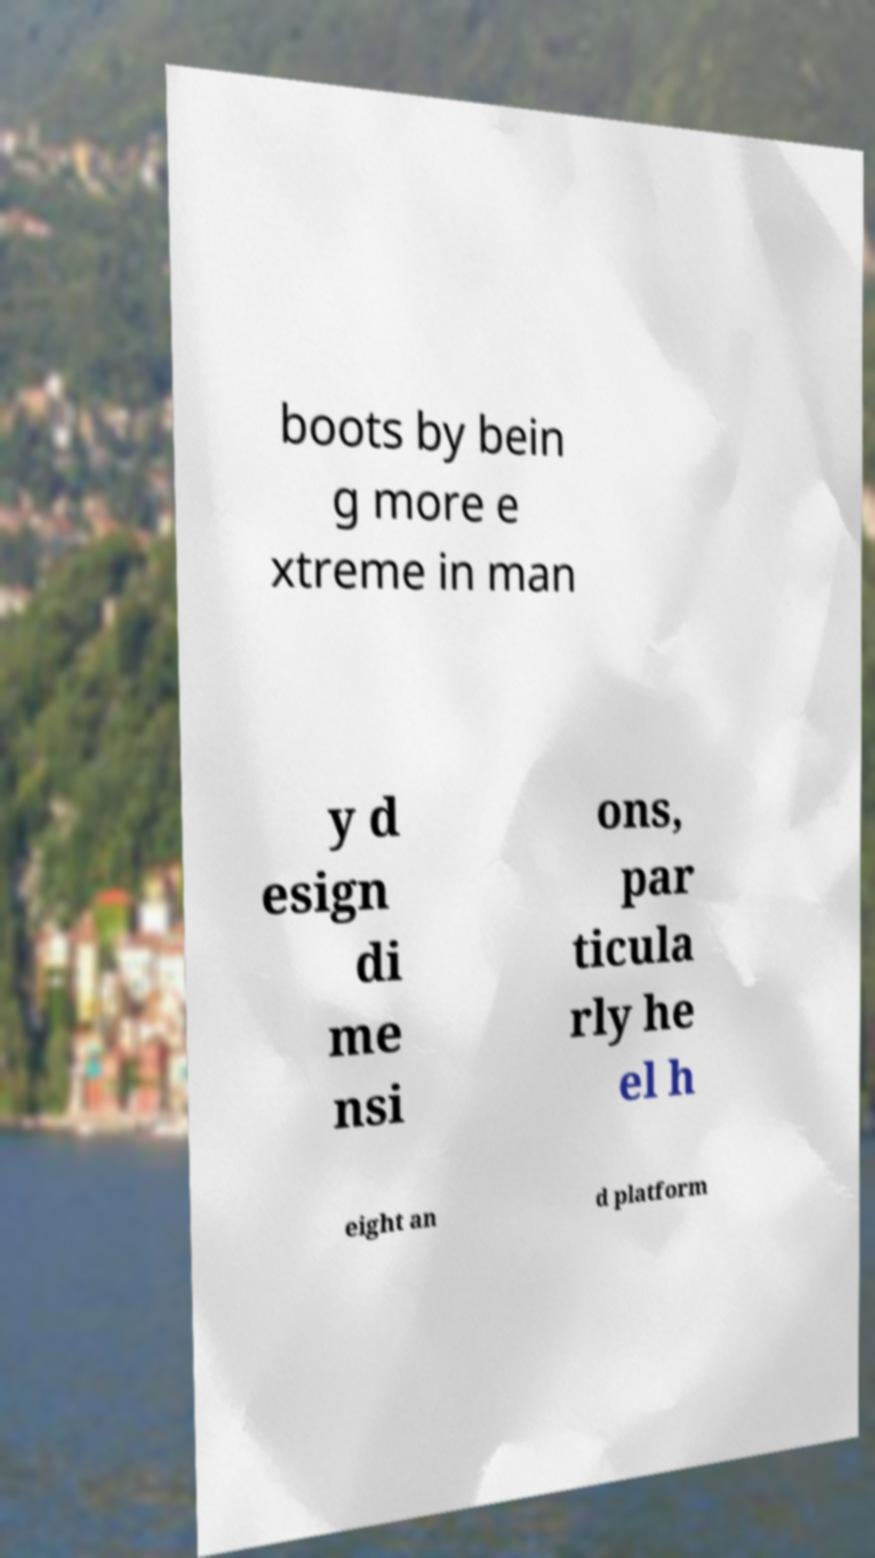I need the written content from this picture converted into text. Can you do that? boots by bein g more e xtreme in man y d esign di me nsi ons, par ticula rly he el h eight an d platform 